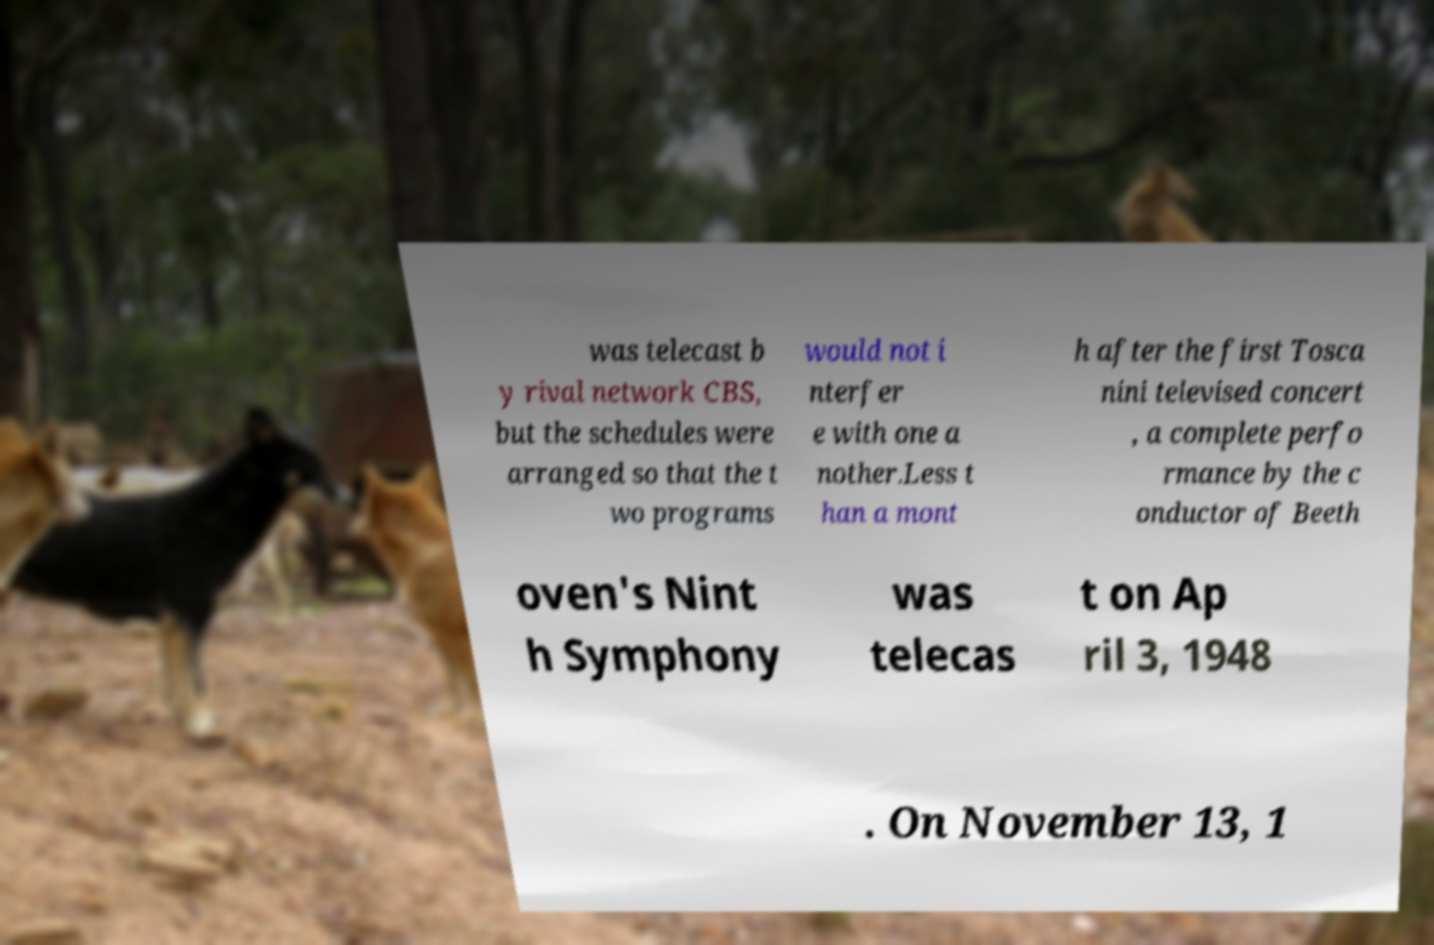Can you accurately transcribe the text from the provided image for me? was telecast b y rival network CBS, but the schedules were arranged so that the t wo programs would not i nterfer e with one a nother.Less t han a mont h after the first Tosca nini televised concert , a complete perfo rmance by the c onductor of Beeth oven's Nint h Symphony was telecas t on Ap ril 3, 1948 . On November 13, 1 